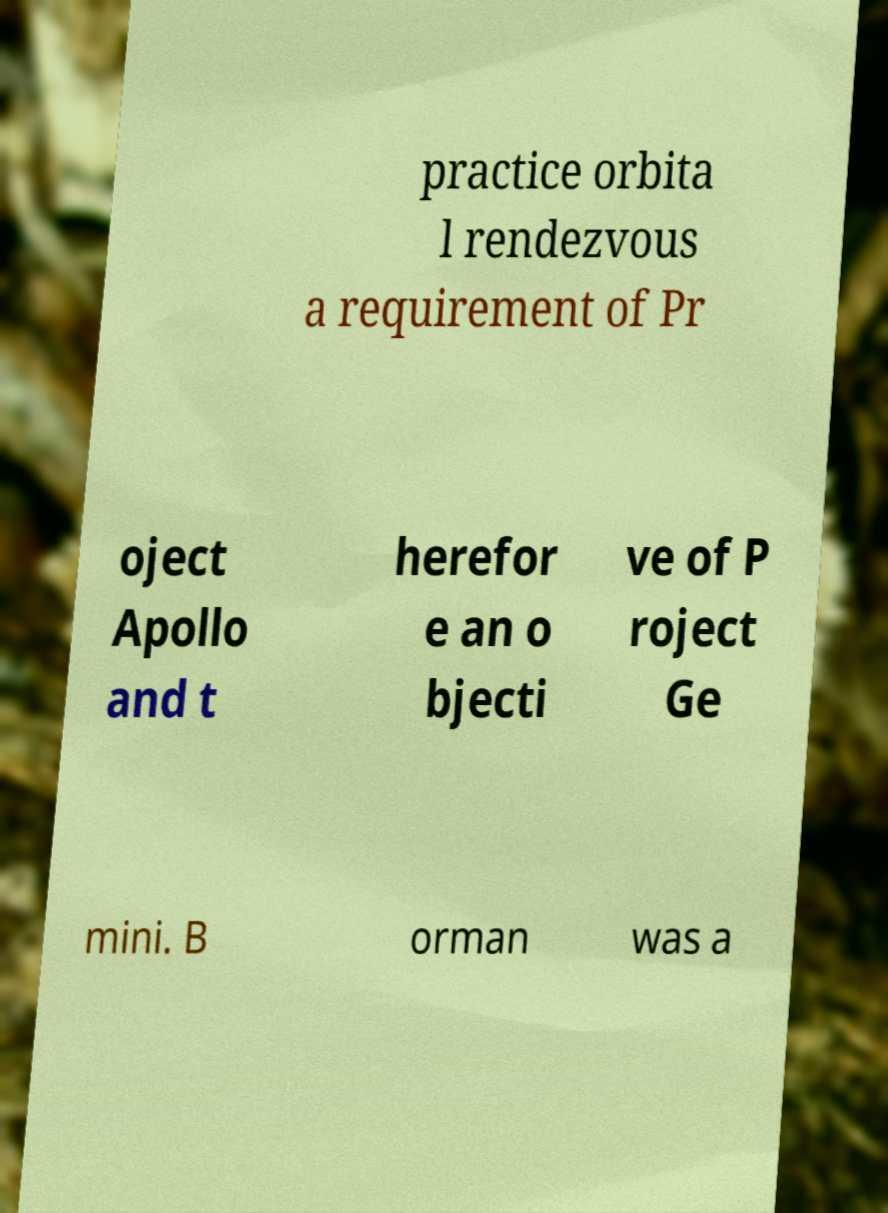There's text embedded in this image that I need extracted. Can you transcribe it verbatim? practice orbita l rendezvous a requirement of Pr oject Apollo and t herefor e an o bjecti ve of P roject Ge mini. B orman was a 